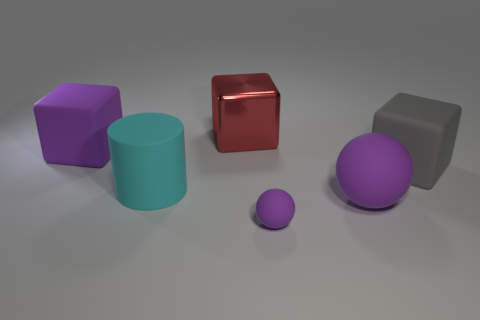Add 3 tiny brown things. How many objects exist? 9 Subtract all large red shiny cubes. How many cubes are left? 2 Subtract 1 blocks. How many blocks are left? 2 Subtract all tiny brown spheres. Subtract all shiny things. How many objects are left? 5 Add 1 large things. How many large things are left? 6 Add 2 small yellow rubber cylinders. How many small yellow rubber cylinders exist? 2 Subtract all purple blocks. How many blocks are left? 2 Subtract 0 yellow spheres. How many objects are left? 6 Subtract all cylinders. How many objects are left? 5 Subtract all yellow spheres. Subtract all green blocks. How many spheres are left? 2 